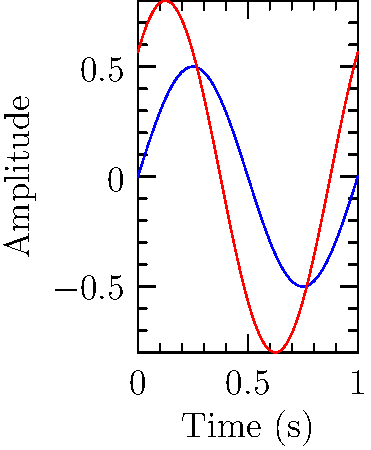Based on the speech waveforms shown for two different languages, what key difference can be observed that might be relevant for a language-related research project? To answer this question, let's analyze the waveforms step-by-step:

1. Amplitude: The red waveform (Language B) has a larger amplitude than the blue waveform (Language A). The maximum displacement from the center line is greater for Language B.

2. Frequency: Both waveforms complete one full cycle in the same time period, indicating that they have the same frequency.

3. Phase: The red waveform (Language B) appears to start at a different point in its cycle compared to the blue waveform (Language A). This indicates a phase difference between the two signals.

4. Shape: Both waveforms are sinusoidal, suggesting they represent simple tones or vowel sounds.

The most significant difference between these waveforms is the amplitude. This could indicate that speakers of Language B tend to speak with greater intensity or volume compared to speakers of Language A. 

For a language-related research project, this amplitude difference could be relevant in studying:
- Prosodic features of languages
- Stress patterns in speech
- Cultural differences in communication style
- Acoustic properties of different languages

The phase difference, while present, is less likely to be linguistically significant in this context.
Answer: Amplitude difference, suggesting variation in speech intensity between languages 